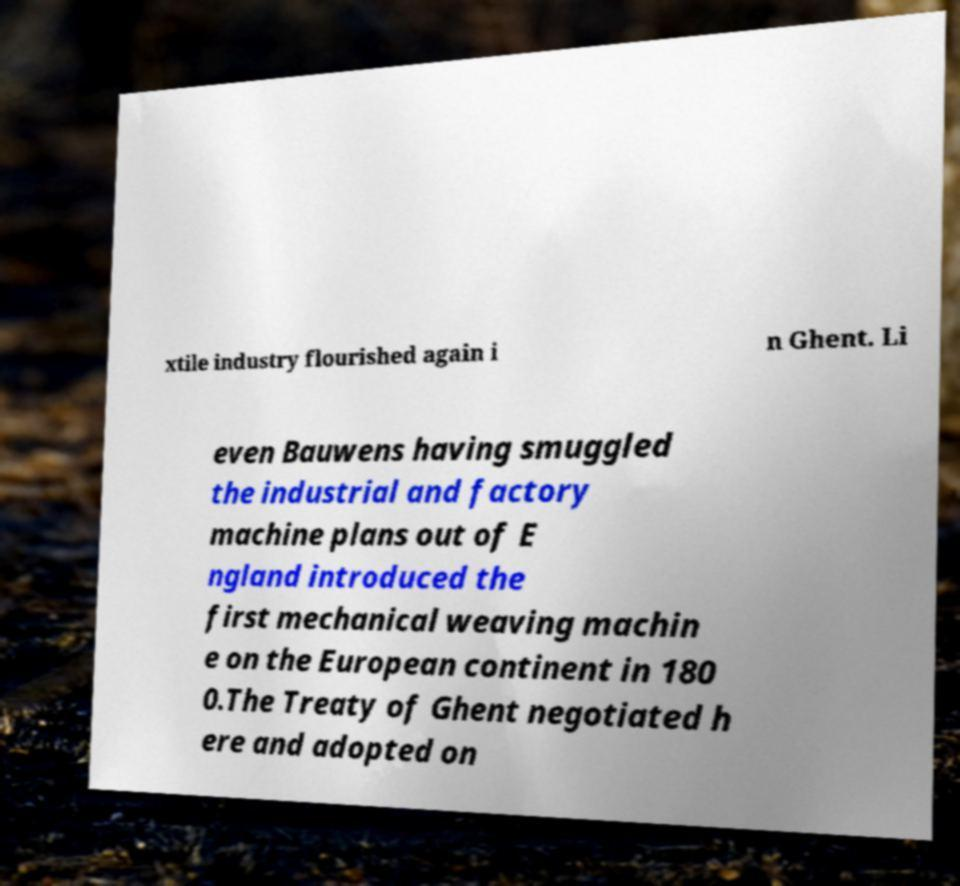Can you read and provide the text displayed in the image?This photo seems to have some interesting text. Can you extract and type it out for me? xtile industry flourished again i n Ghent. Li even Bauwens having smuggled the industrial and factory machine plans out of E ngland introduced the first mechanical weaving machin e on the European continent in 180 0.The Treaty of Ghent negotiated h ere and adopted on 